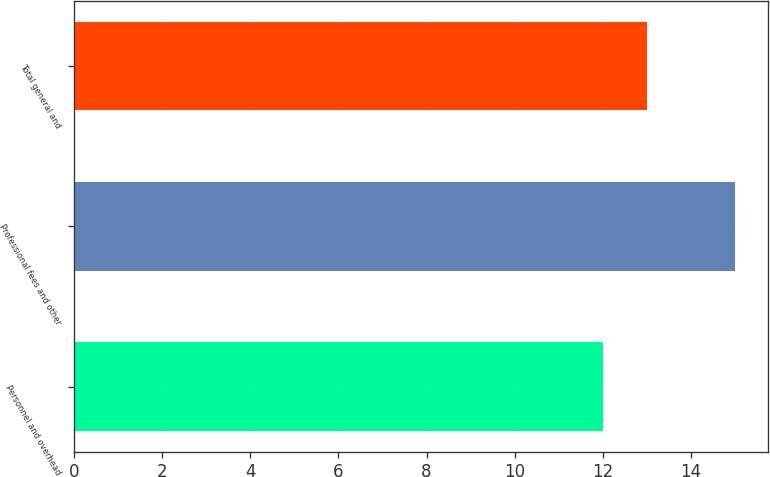<chart> <loc_0><loc_0><loc_500><loc_500><bar_chart><fcel>Personnel and overhead<fcel>Professional fees and other<fcel>Total general and<nl><fcel>12<fcel>15<fcel>13<nl></chart> 